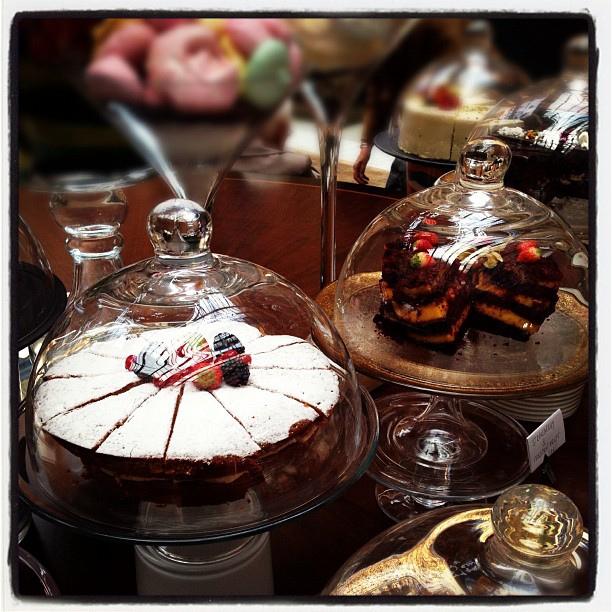How many platters are shown?
Concise answer only. 5. Are these foods a healthy diet?
Keep it brief. No. What type of food is on the platters?
Short answer required. Cake. 